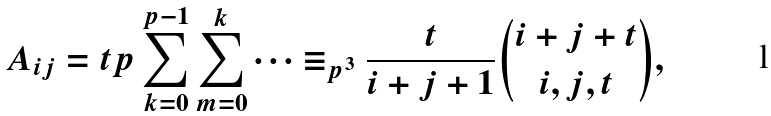Convert formula to latex. <formula><loc_0><loc_0><loc_500><loc_500>A _ { i j } = t p \sum _ { k = 0 } ^ { p - 1 } \sum _ { m = 0 } ^ { k } \cdots & \equiv _ { p ^ { 3 } } \frac { t } { i + j + 1 } \binom { i + j + t } { i , j , t } ,</formula> 